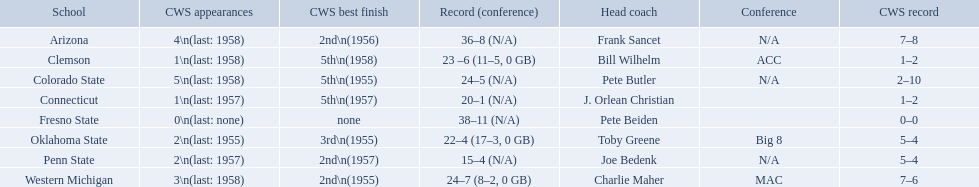How many cws appearances does clemson have? 1\n(last: 1958). How many cws appearances does western michigan have? 3\n(last: 1958). Which of these schools has more cws appearances? Western Michigan. 